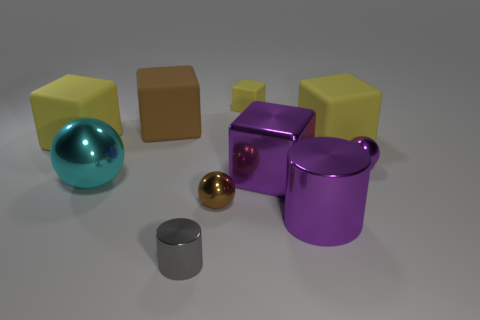Subtract all blue cylinders. How many yellow cubes are left? 3 Subtract all small brown metal balls. How many balls are left? 2 Subtract 3 blocks. How many blocks are left? 2 Subtract all brown blocks. How many blocks are left? 4 Subtract all balls. How many objects are left? 7 Subtract all brown cubes. Subtract all cyan cylinders. How many cubes are left? 4 Subtract all brown objects. Subtract all tiny brown metal objects. How many objects are left? 7 Add 1 small purple objects. How many small purple objects are left? 2 Add 4 tiny purple shiny cylinders. How many tiny purple shiny cylinders exist? 4 Subtract 0 blue cylinders. How many objects are left? 10 